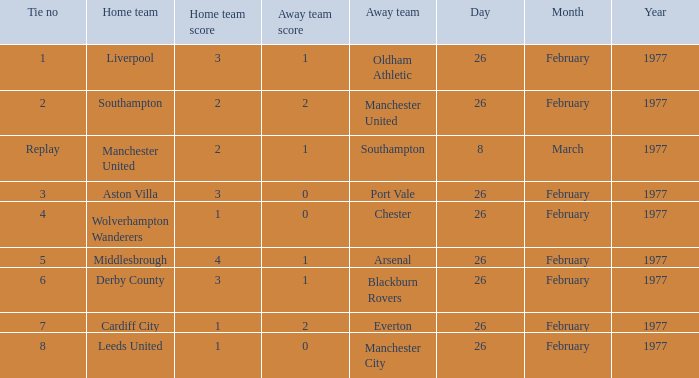What's the score when the tie number was replay? 2–1. 